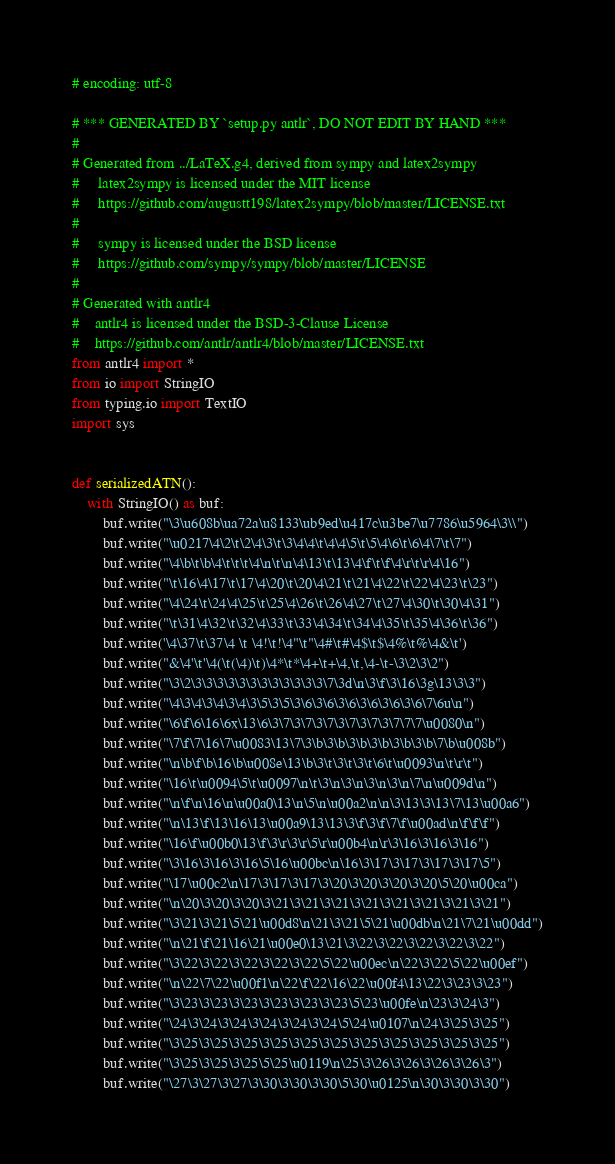Convert code to text. <code><loc_0><loc_0><loc_500><loc_500><_Python_># encoding: utf-8

# *** GENERATED BY `setup.py antlr`, DO NOT EDIT BY HAND ***
#
# Generated from ../LaTeX.g4, derived from sympy and latex2sympy
#     latex2sympy is licensed under the MIT license
#     https://github.com/augustt198/latex2sympy/blob/master/LICENSE.txt
#
#     sympy is licensed under the BSD license
#     https://github.com/sympy/sympy/blob/master/LICENSE
#
# Generated with antlr4
#    antlr4 is licensed under the BSD-3-Clause License
#    https://github.com/antlr/antlr4/blob/master/LICENSE.txt
from antlr4 import *
from io import StringIO
from typing.io import TextIO
import sys


def serializedATN():
    with StringIO() as buf:
        buf.write("\3\u608b\ua72a\u8133\ub9ed\u417c\u3be7\u7786\u5964\3\\")
        buf.write("\u0217\4\2\t\2\4\3\t\3\4\4\t\4\4\5\t\5\4\6\t\6\4\7\t\7")
        buf.write("\4\b\t\b\4\t\t\t\4\n\t\n\4\13\t\13\4\f\t\f\4\r\t\r\4\16")
        buf.write("\t\16\4\17\t\17\4\20\t\20\4\21\t\21\4\22\t\22\4\23\t\23")
        buf.write("\4\24\t\24\4\25\t\25\4\26\t\26\4\27\t\27\4\30\t\30\4\31")
        buf.write("\t\31\4\32\t\32\4\33\t\33\4\34\t\34\4\35\t\35\4\36\t\36")
        buf.write('\4\37\t\37\4 \t \4!\t!\4"\t"\4#\t#\4$\t$\4%\t%\4&\t')
        buf.write("&\4'\t'\4(\t(\4)\t)\4*\t*\4+\t+\4,\t,\4-\t-\3\2\3\2")
        buf.write("\3\2\3\3\3\3\3\3\3\3\3\3\3\3\7\3d\n\3\f\3\16\3g\13\3\3")
        buf.write("\4\3\4\3\4\3\4\3\5\3\5\3\6\3\6\3\6\3\6\3\6\3\6\7\6u\n")
        buf.write("\6\f\6\16\6x\13\6\3\7\3\7\3\7\3\7\3\7\3\7\7\7\u0080\n")
        buf.write("\7\f\7\16\7\u0083\13\7\3\b\3\b\3\b\3\b\3\b\3\b\7\b\u008b")
        buf.write("\n\b\f\b\16\b\u008e\13\b\3\t\3\t\3\t\6\t\u0093\n\t\r\t")
        buf.write("\16\t\u0094\5\t\u0097\n\t\3\n\3\n\3\n\3\n\7\n\u009d\n")
        buf.write("\n\f\n\16\n\u00a0\13\n\5\n\u00a2\n\n\3\13\3\13\7\13\u00a6")
        buf.write("\n\13\f\13\16\13\u00a9\13\13\3\f\3\f\7\f\u00ad\n\f\f\f")
        buf.write("\16\f\u00b0\13\f\3\r\3\r\5\r\u00b4\n\r\3\16\3\16\3\16")
        buf.write("\3\16\3\16\3\16\5\16\u00bc\n\16\3\17\3\17\3\17\3\17\5")
        buf.write("\17\u00c2\n\17\3\17\3\17\3\20\3\20\3\20\3\20\5\20\u00ca")
        buf.write("\n\20\3\20\3\20\3\21\3\21\3\21\3\21\3\21\3\21\3\21\3\21")
        buf.write("\3\21\3\21\5\21\u00d8\n\21\3\21\5\21\u00db\n\21\7\21\u00dd")
        buf.write("\n\21\f\21\16\21\u00e0\13\21\3\22\3\22\3\22\3\22\3\22")
        buf.write("\3\22\3\22\3\22\3\22\3\22\5\22\u00ec\n\22\3\22\5\22\u00ef")
        buf.write("\n\22\7\22\u00f1\n\22\f\22\16\22\u00f4\13\22\3\23\3\23")
        buf.write("\3\23\3\23\3\23\3\23\3\23\3\23\5\23\u00fe\n\23\3\24\3")
        buf.write("\24\3\24\3\24\3\24\3\24\3\24\5\24\u0107\n\24\3\25\3\25")
        buf.write("\3\25\3\25\3\25\3\25\3\25\3\25\3\25\3\25\3\25\3\25\3\25")
        buf.write("\3\25\3\25\3\25\5\25\u0119\n\25\3\26\3\26\3\26\3\26\3")
        buf.write("\27\3\27\3\27\3\30\3\30\3\30\5\30\u0125\n\30\3\30\3\30")</code> 